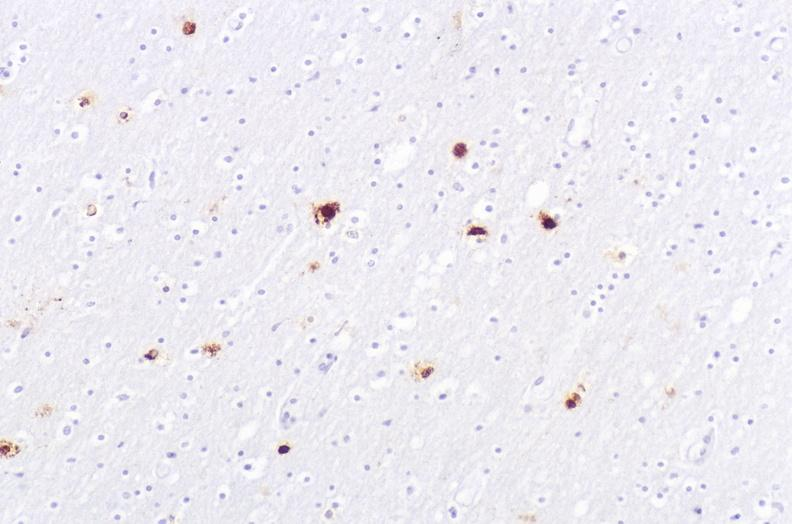what is present?
Answer the question using a single word or phrase. Nervous 